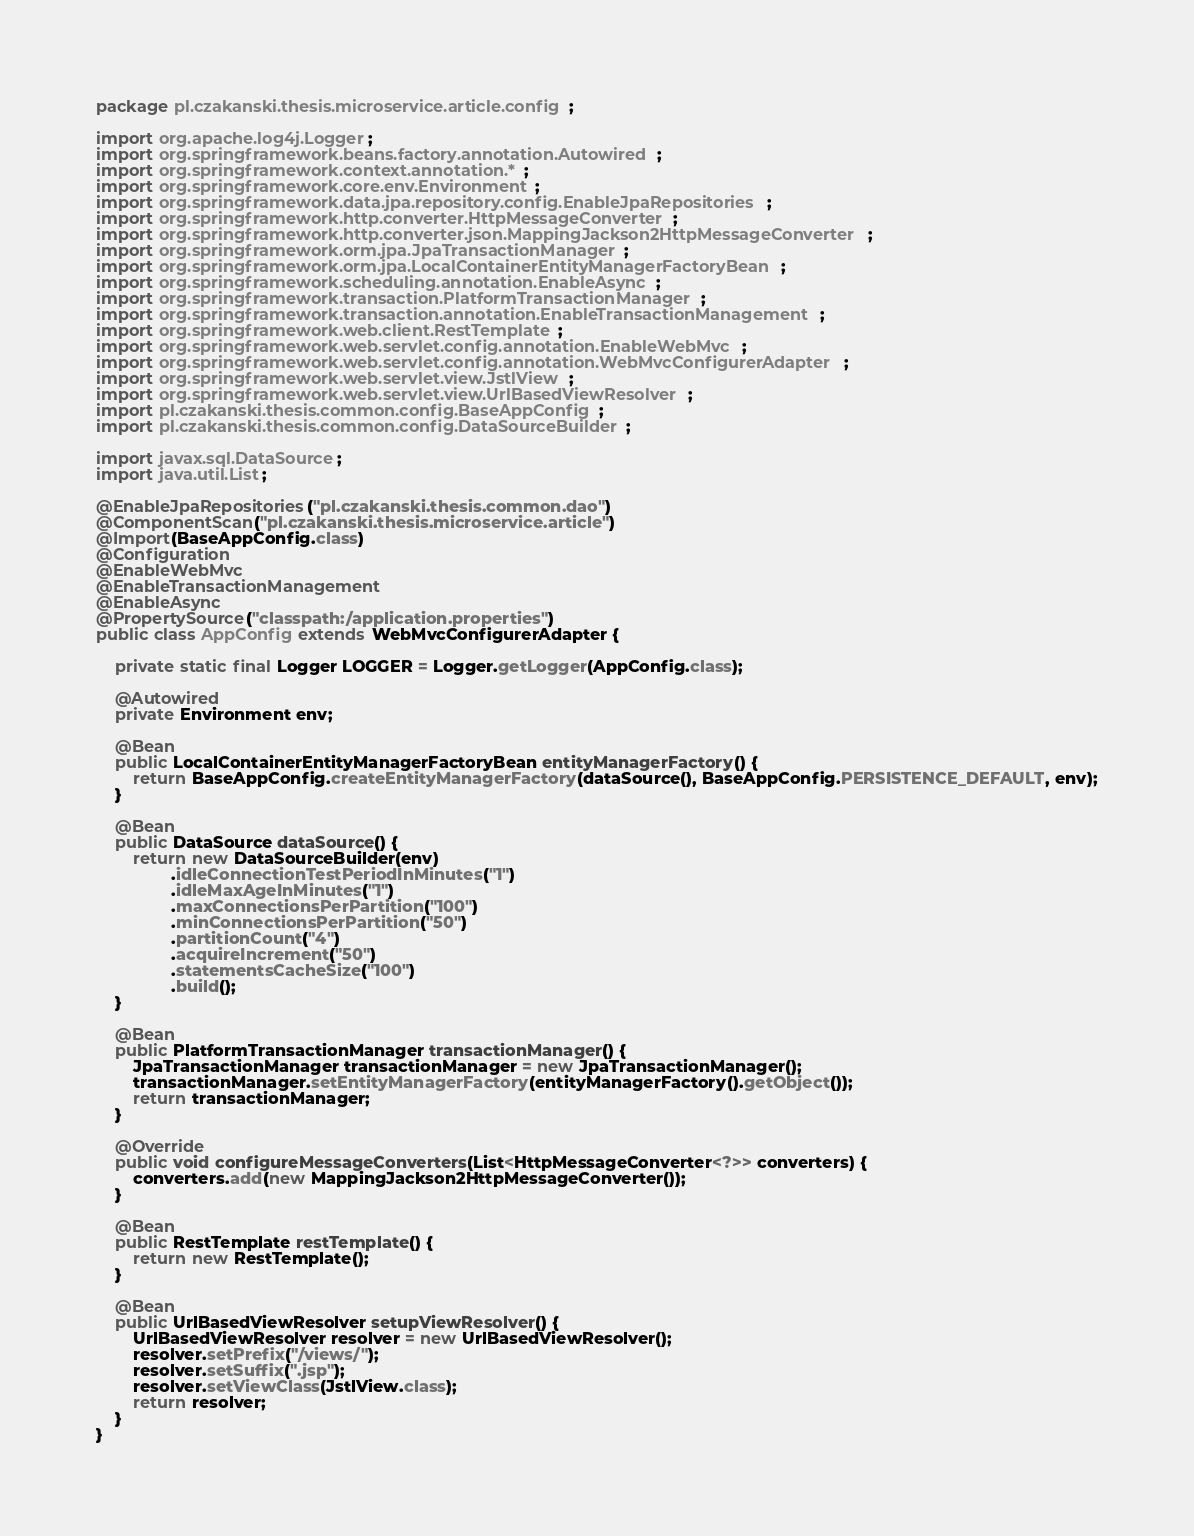<code> <loc_0><loc_0><loc_500><loc_500><_Java_>package pl.czakanski.thesis.microservice.article.config;

import org.apache.log4j.Logger;
import org.springframework.beans.factory.annotation.Autowired;
import org.springframework.context.annotation.*;
import org.springframework.core.env.Environment;
import org.springframework.data.jpa.repository.config.EnableJpaRepositories;
import org.springframework.http.converter.HttpMessageConverter;
import org.springframework.http.converter.json.MappingJackson2HttpMessageConverter;
import org.springframework.orm.jpa.JpaTransactionManager;
import org.springframework.orm.jpa.LocalContainerEntityManagerFactoryBean;
import org.springframework.scheduling.annotation.EnableAsync;
import org.springframework.transaction.PlatformTransactionManager;
import org.springframework.transaction.annotation.EnableTransactionManagement;
import org.springframework.web.client.RestTemplate;
import org.springframework.web.servlet.config.annotation.EnableWebMvc;
import org.springframework.web.servlet.config.annotation.WebMvcConfigurerAdapter;
import org.springframework.web.servlet.view.JstlView;
import org.springframework.web.servlet.view.UrlBasedViewResolver;
import pl.czakanski.thesis.common.config.BaseAppConfig;
import pl.czakanski.thesis.common.config.DataSourceBuilder;

import javax.sql.DataSource;
import java.util.List;

@EnableJpaRepositories("pl.czakanski.thesis.common.dao")
@ComponentScan("pl.czakanski.thesis.microservice.article")
@Import(BaseAppConfig.class)
@Configuration
@EnableWebMvc
@EnableTransactionManagement
@EnableAsync
@PropertySource("classpath:/application.properties")
public class AppConfig extends WebMvcConfigurerAdapter {

	private static final Logger LOGGER = Logger.getLogger(AppConfig.class);

	@Autowired
	private Environment env;

	@Bean
	public LocalContainerEntityManagerFactoryBean entityManagerFactory() {
		return BaseAppConfig.createEntityManagerFactory(dataSource(), BaseAppConfig.PERSISTENCE_DEFAULT, env);
	}

	@Bean
	public DataSource dataSource() {
		return new DataSourceBuilder(env)
				.idleConnectionTestPeriodInMinutes("1")
				.idleMaxAgeInMinutes("1")
				.maxConnectionsPerPartition("100")
				.minConnectionsPerPartition("50")
				.partitionCount("4")
				.acquireIncrement("50")
				.statementsCacheSize("100")
				.build();
	}

	@Bean
	public PlatformTransactionManager transactionManager() {
		JpaTransactionManager transactionManager = new JpaTransactionManager();
		transactionManager.setEntityManagerFactory(entityManagerFactory().getObject());
		return transactionManager;
	}

	@Override
	public void configureMessageConverters(List<HttpMessageConverter<?>> converters) {
		converters.add(new MappingJackson2HttpMessageConverter());
	}

	@Bean
	public RestTemplate restTemplate() {
		return new RestTemplate();
	}

	@Bean
	public UrlBasedViewResolver setupViewResolver() {
		UrlBasedViewResolver resolver = new UrlBasedViewResolver();
		resolver.setPrefix("/views/");
		resolver.setSuffix(".jsp");
		resolver.setViewClass(JstlView.class);
		return resolver;
	}
}</code> 